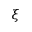Convert formula to latex. <formula><loc_0><loc_0><loc_500><loc_500>\xi</formula> 